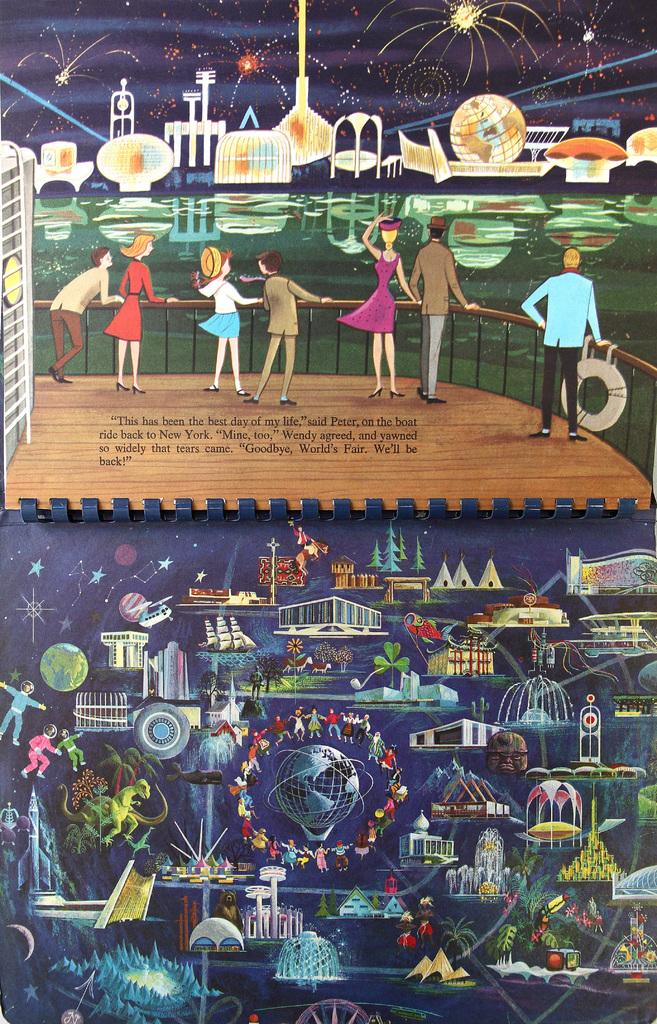Provide a one-sentence caption for the provided image. A page of a book where peter and wendy agree that this has been the best day of their life. 